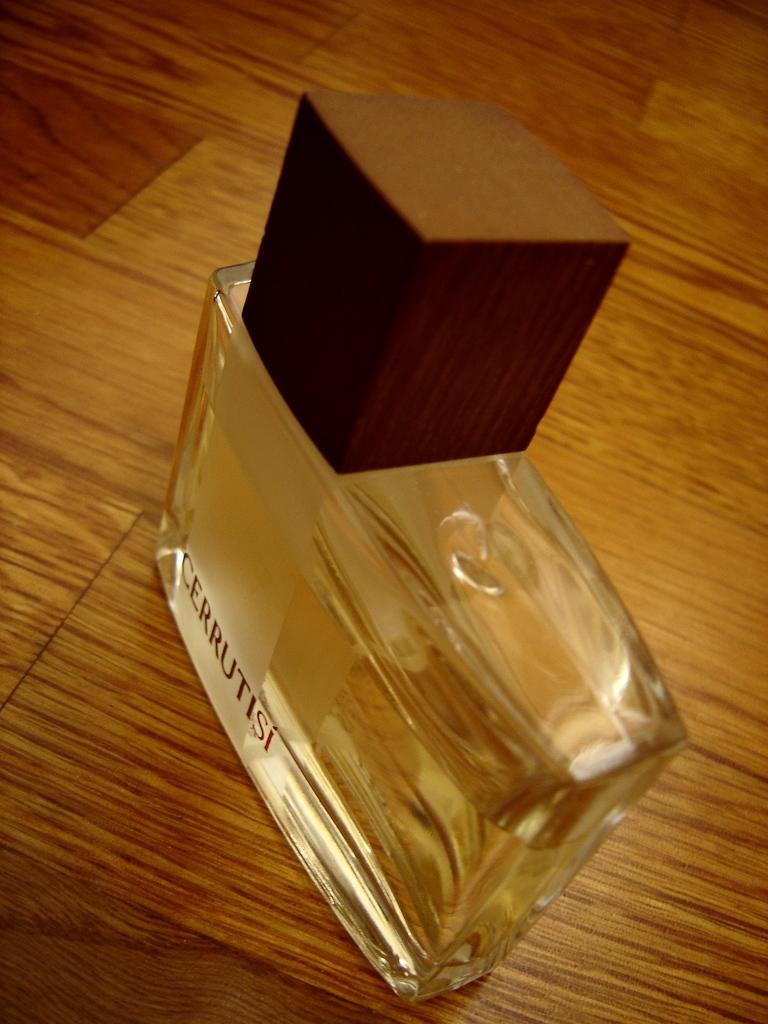<image>
Create a compact narrative representing the image presented. A bottle of Cerrutisi perfume on a wooden floor. 